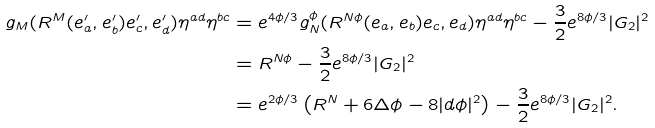<formula> <loc_0><loc_0><loc_500><loc_500>g _ { M } ( R ^ { M } ( e _ { a } ^ { \prime } , e _ { b } ^ { \prime } ) e _ { c } ^ { \prime } , e _ { d } ^ { \prime } ) \eta ^ { a d } \eta ^ { b c } & = e ^ { 4 \phi / 3 } g _ { N } ^ { \phi } ( R ^ { N \phi } ( e _ { a } , e _ { b } ) e _ { c } , e _ { d } ) \eta ^ { a d } \eta ^ { b c } - \frac { 3 } { 2 } e ^ { 8 \phi / 3 } | G _ { 2 } | ^ { 2 } \\ & = R ^ { N \phi } - \frac { 3 } { 2 } e ^ { 8 \phi / 3 } | G _ { 2 } | ^ { 2 } \\ & = e ^ { 2 \phi / 3 } \left ( R ^ { N } + 6 \Delta \phi - 8 | d \phi | ^ { 2 } \right ) - \frac { 3 } { 2 } e ^ { 8 \phi / 3 } | G _ { 2 } | ^ { 2 } .</formula> 